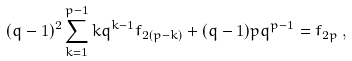<formula> <loc_0><loc_0><loc_500><loc_500>( q - 1 ) ^ { 2 } \sum _ { k = 1 } ^ { p - 1 } k q ^ { k - 1 } f _ { 2 ( p - k ) } + ( q - 1 ) p q ^ { p - 1 } = f _ { 2 p } \, ,</formula> 